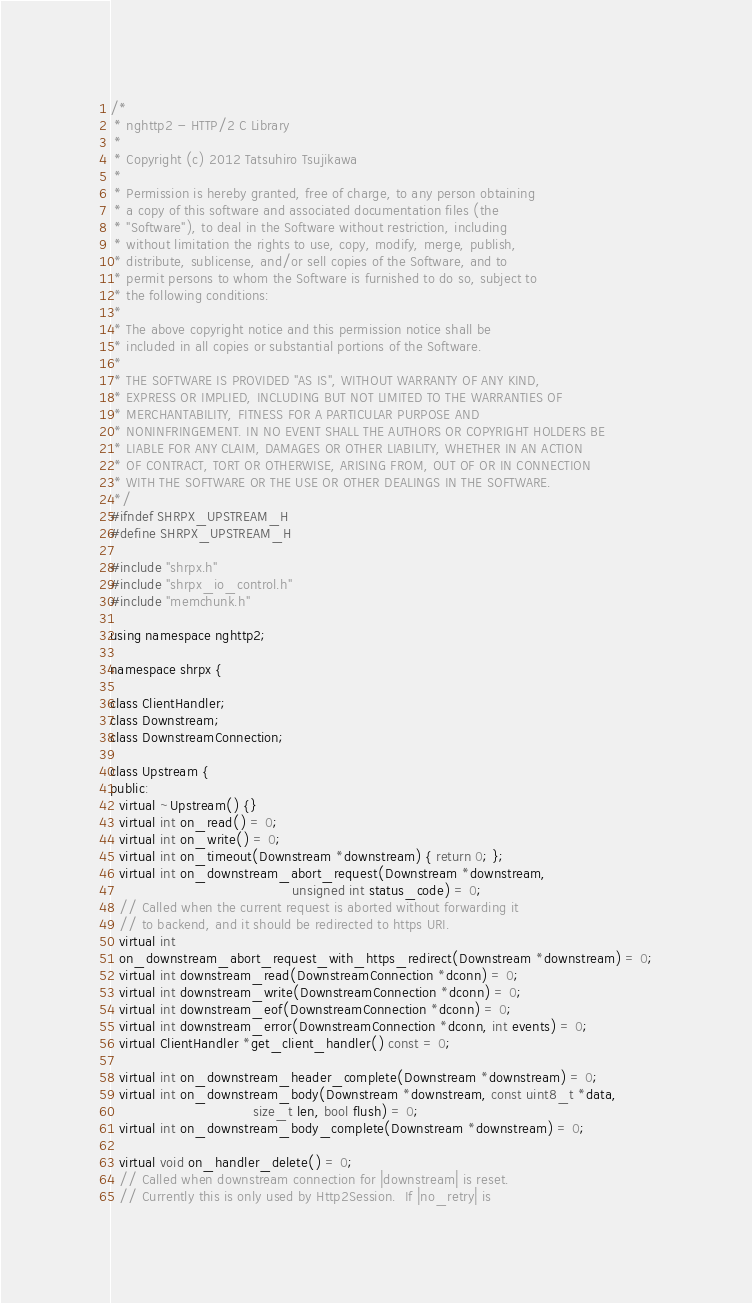<code> <loc_0><loc_0><loc_500><loc_500><_C_>/*
 * nghttp2 - HTTP/2 C Library
 *
 * Copyright (c) 2012 Tatsuhiro Tsujikawa
 *
 * Permission is hereby granted, free of charge, to any person obtaining
 * a copy of this software and associated documentation files (the
 * "Software"), to deal in the Software without restriction, including
 * without limitation the rights to use, copy, modify, merge, publish,
 * distribute, sublicense, and/or sell copies of the Software, and to
 * permit persons to whom the Software is furnished to do so, subject to
 * the following conditions:
 *
 * The above copyright notice and this permission notice shall be
 * included in all copies or substantial portions of the Software.
 *
 * THE SOFTWARE IS PROVIDED "AS IS", WITHOUT WARRANTY OF ANY KIND,
 * EXPRESS OR IMPLIED, INCLUDING BUT NOT LIMITED TO THE WARRANTIES OF
 * MERCHANTABILITY, FITNESS FOR A PARTICULAR PURPOSE AND
 * NONINFRINGEMENT. IN NO EVENT SHALL THE AUTHORS OR COPYRIGHT HOLDERS BE
 * LIABLE FOR ANY CLAIM, DAMAGES OR OTHER LIABILITY, WHETHER IN AN ACTION
 * OF CONTRACT, TORT OR OTHERWISE, ARISING FROM, OUT OF OR IN CONNECTION
 * WITH THE SOFTWARE OR THE USE OR OTHER DEALINGS IN THE SOFTWARE.
 */
#ifndef SHRPX_UPSTREAM_H
#define SHRPX_UPSTREAM_H

#include "shrpx.h"
#include "shrpx_io_control.h"
#include "memchunk.h"

using namespace nghttp2;

namespace shrpx {

class ClientHandler;
class Downstream;
class DownstreamConnection;

class Upstream {
public:
  virtual ~Upstream() {}
  virtual int on_read() = 0;
  virtual int on_write() = 0;
  virtual int on_timeout(Downstream *downstream) { return 0; };
  virtual int on_downstream_abort_request(Downstream *downstream,
                                          unsigned int status_code) = 0;
  // Called when the current request is aborted without forwarding it
  // to backend, and it should be redirected to https URI.
  virtual int
  on_downstream_abort_request_with_https_redirect(Downstream *downstream) = 0;
  virtual int downstream_read(DownstreamConnection *dconn) = 0;
  virtual int downstream_write(DownstreamConnection *dconn) = 0;
  virtual int downstream_eof(DownstreamConnection *dconn) = 0;
  virtual int downstream_error(DownstreamConnection *dconn, int events) = 0;
  virtual ClientHandler *get_client_handler() const = 0;

  virtual int on_downstream_header_complete(Downstream *downstream) = 0;
  virtual int on_downstream_body(Downstream *downstream, const uint8_t *data,
                                 size_t len, bool flush) = 0;
  virtual int on_downstream_body_complete(Downstream *downstream) = 0;

  virtual void on_handler_delete() = 0;
  // Called when downstream connection for |downstream| is reset.
  // Currently this is only used by Http2Session.  If |no_retry| is</code> 